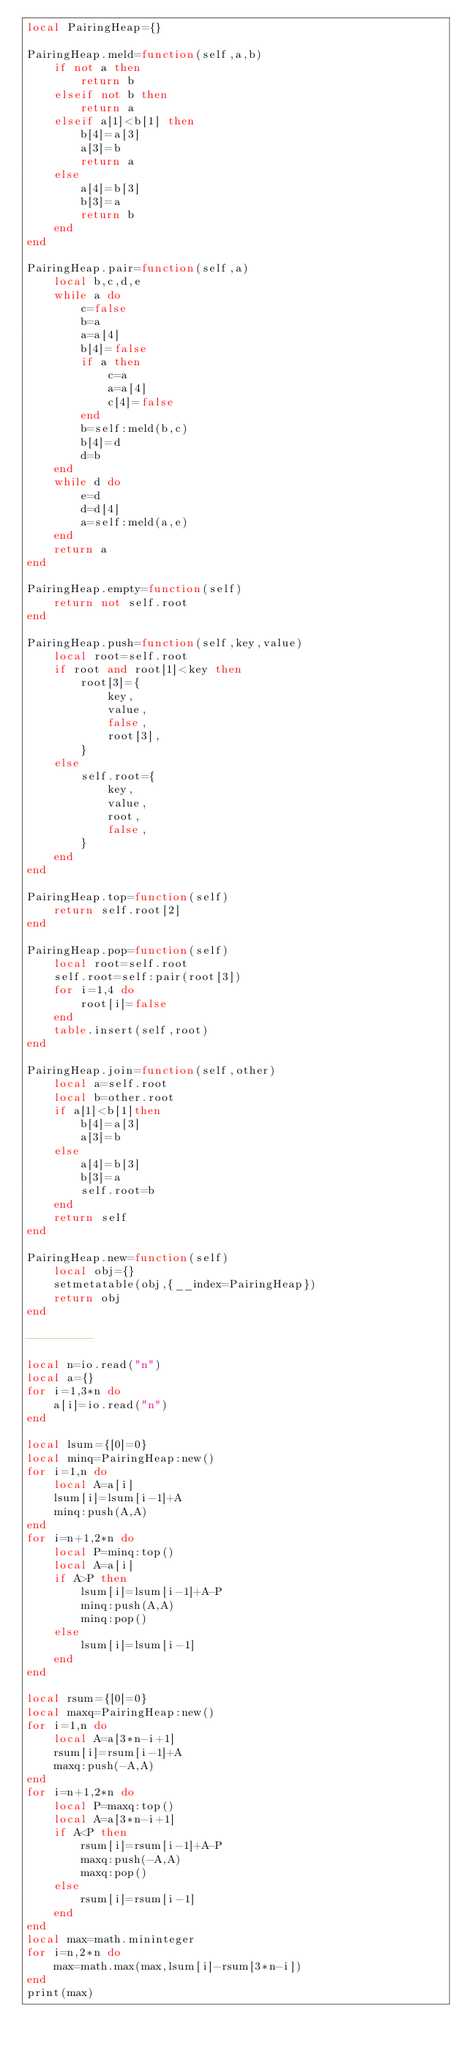<code> <loc_0><loc_0><loc_500><loc_500><_Lua_>local PairingHeap={}

PairingHeap.meld=function(self,a,b)
    if not a then
        return b
    elseif not b then
        return a
    elseif a[1]<b[1] then
        b[4]=a[3]
        a[3]=b
        return a
    else
        a[4]=b[3]
        b[3]=a
        return b
    end
end

PairingHeap.pair=function(self,a)
    local b,c,d,e
    while a do
        c=false
        b=a
        a=a[4]
        b[4]=false
        if a then
            c=a
            a=a[4]   
            c[4]=false
        end
        b=self:meld(b,c)
        b[4]=d
        d=b
    end
    while d do
        e=d
        d=d[4]
        a=self:meld(a,e)
    end
    return a
end

PairingHeap.empty=function(self)
    return not self.root
end

PairingHeap.push=function(self,key,value)
    local root=self.root
    if root and root[1]<key then
        root[3]={
            key,
            value,
            false,
            root[3],
        }
    else
        self.root={
            key,
            value,
            root,
            false,
        }
    end
end

PairingHeap.top=function(self)
	return self.root[2]
end

PairingHeap.pop=function(self)
    local root=self.root
    self.root=self:pair(root[3])
    for i=1,4 do
        root[i]=false
    end
    table.insert(self,root)
end

PairingHeap.join=function(self,other)
    local a=self.root
    local b=other.root
    if a[1]<b[1]then
        b[4]=a[3]
        a[3]=b
    else
        a[4]=b[3]
        b[3]=a
        self.root=b
    end
    return self
end

PairingHeap.new=function(self)
    local obj={}
    setmetatable(obj,{__index=PairingHeap})
    return obj
end

----------

local n=io.read("n")
local a={}
for i=1,3*n do
    a[i]=io.read("n")
end

local lsum={[0]=0}
local minq=PairingHeap:new()
for i=1,n do
    local A=a[i]
    lsum[i]=lsum[i-1]+A
    minq:push(A,A)
end
for i=n+1,2*n do
    local P=minq:top()
    local A=a[i]
    if A>P then
        lsum[i]=lsum[i-1]+A-P
        minq:push(A,A)
        minq:pop()
    else
        lsum[i]=lsum[i-1]
    end
end

local rsum={[0]=0}
local maxq=PairingHeap:new()
for i=1,n do
    local A=a[3*n-i+1]
    rsum[i]=rsum[i-1]+A
    maxq:push(-A,A)
end
for i=n+1,2*n do
    local P=maxq:top()
    local A=a[3*n-i+1]
    if A<P then
        rsum[i]=rsum[i-1]+A-P
        maxq:push(-A,A)
        maxq:pop()
    else
        rsum[i]=rsum[i-1]
    end
end
local max=math.mininteger
for i=n,2*n do
    max=math.max(max,lsum[i]-rsum[3*n-i])
end
print(max)</code> 